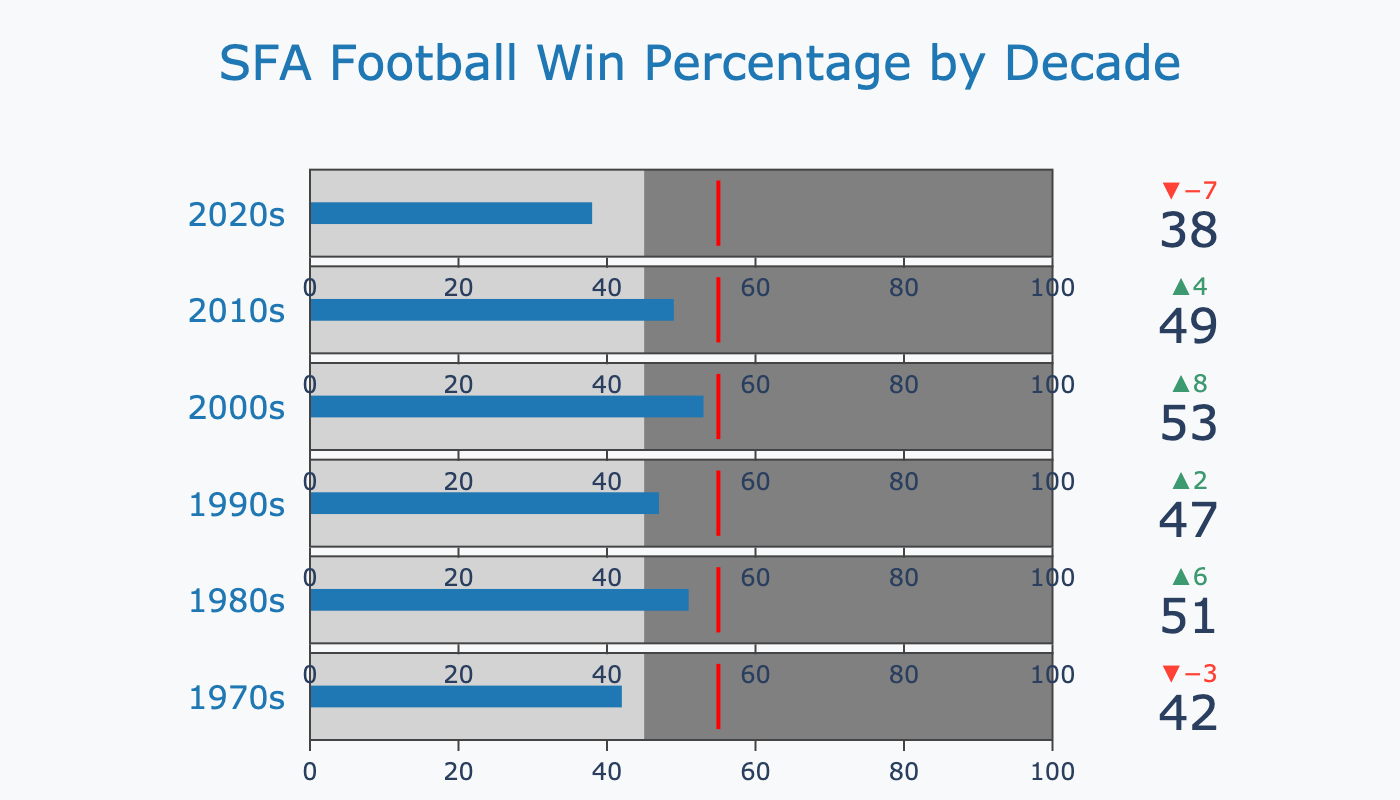What's the title of the bullet chart? The title of the chart is located at the top center of the figure and usually describes the main subject of the data.
Answer: SFA Football Win Percentage by Decade What is the win percentage for Stephen F. Austin State University football during the 1980s? To find this, look at the bullet chart's label for the 1980s and note the value given for that decade.
Answer: 51 What decades had a win percentage below the average of 45%? To determine this, compare the win percentages of each decade to the average value of 45%. The 1970s and 2020s fall below this average.
Answer: 1970s, 2020s Which decade had the highest win percentage? Look at all the win percentage values and identify the highest one. The 2000s have the highest win percentage of 53.
Answer: 2000s By how much did the win percentage for the 2010s exceed the average? Subtract the average value (45%) from the 2010s win percentage (49%). 49 - 45 = 4.
Answer: 4 Which decade is furthest from reaching the target percentage of 55%? To find this, calculate the difference between each decade's win percentage and the target of 55%. The 2020s (38) is furthest away: 55 - 38 = 17.
Answer: 2020s How many decades had win percentages that are above the average? Count the number of decades with win percentages greater than 45%. There are four such decades: 1980s, 1990s, 2000s, 2010s.
Answer: 4 Which decade showed the smallest difference between its win percentage and the target percentage of 55%? Calculate the difference between each decade's win percentage and the target. The 2000s have the smallest difference of 2 (55 - 53 = 2).
Answer: 2000s How does the win percentage trend change from the 2010s to the 2020s? Compare the win percentages of the 2010s and 2020s. The win percentage drops from 49% in the 2010s to 38% in the 2020s.
Answer: Decline For the 2000s, how much did the win percentage exceed the average and how close was it to the target? The 2000s win percentage is 53. Subtract the average (45) from the win percentage to find the excess: 53 - 45 = 8. To find closeness to the target, subtract the win percentage from the target: 55 - 53 = 2.
Answer: Exceeded by 8, 2 away from target 